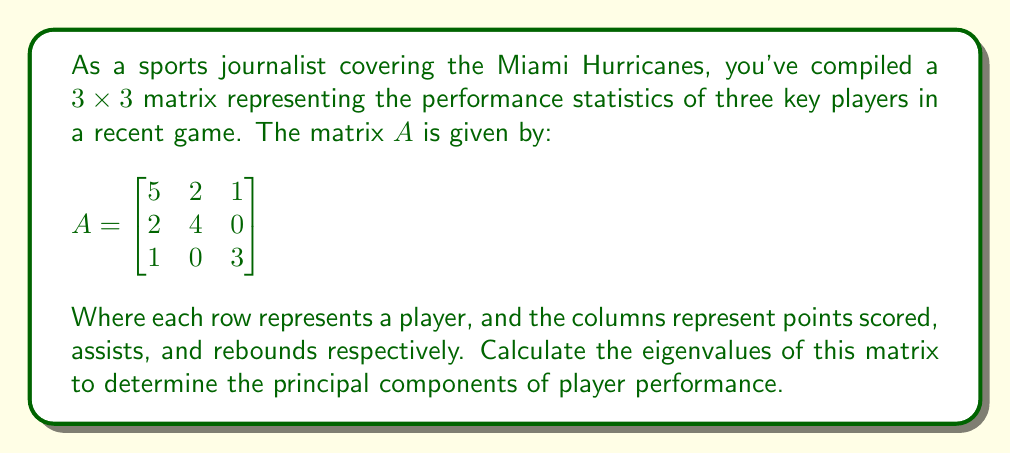Teach me how to tackle this problem. To find the eigenvalues of matrix A, we need to solve the characteristic equation:

1) First, we set up the equation $det(A - \lambda I) = 0$, where $\lambda$ represents the eigenvalues and I is the 3x3 identity matrix:

   $$det\begin{pmatrix}
   5-\lambda & 2 & 1 \\
   2 & 4-\lambda & 0 \\
   1 & 0 & 3-\lambda
   \end{pmatrix} = 0$$

2) Expand the determinant:
   $$(5-\lambda)[(4-\lambda)(3-\lambda) - 0] - 2[2(3-\lambda) - 0] + 1[2(0) - 1(4-\lambda)] = 0$$

3) Simplify:
   $$(5-\lambda)(12-7\lambda+\lambda^2) - 2(6-2\lambda) + (4-\lambda) = 0$$

4) Expand further:
   $$60-35\lambda+5\lambda^2-12\lambda+7\lambda^2-\lambda^3 - 12+4\lambda + 4-\lambda = 0$$

5) Collect terms:
   $$-\lambda^3 + 12\lambda^2 - 44\lambda + 52 = 0$$

6) This is a cubic equation. We can factor out $(\lambda - 2)$:
   $$(\lambda - 2)(-\lambda^2 + 10\lambda - 26) = 0$$

7) Using the quadratic formula for $-\lambda^2 + 10\lambda - 26 = 0$, we get:
   $$\lambda = \frac{10 \pm \sqrt{100 - 4(-1)(-26)}}{2(-1)} = \frac{10 \pm \sqrt{4}}{-2} = \frac{10 \pm 2}{-2}$$

8) Therefore, the other two roots are:
   $$\lambda = 6$$ or $$\lambda = 4$$

Thus, the eigenvalues are 2, 4, and 6.
Answer: $\lambda = 2, 4, 6$ 